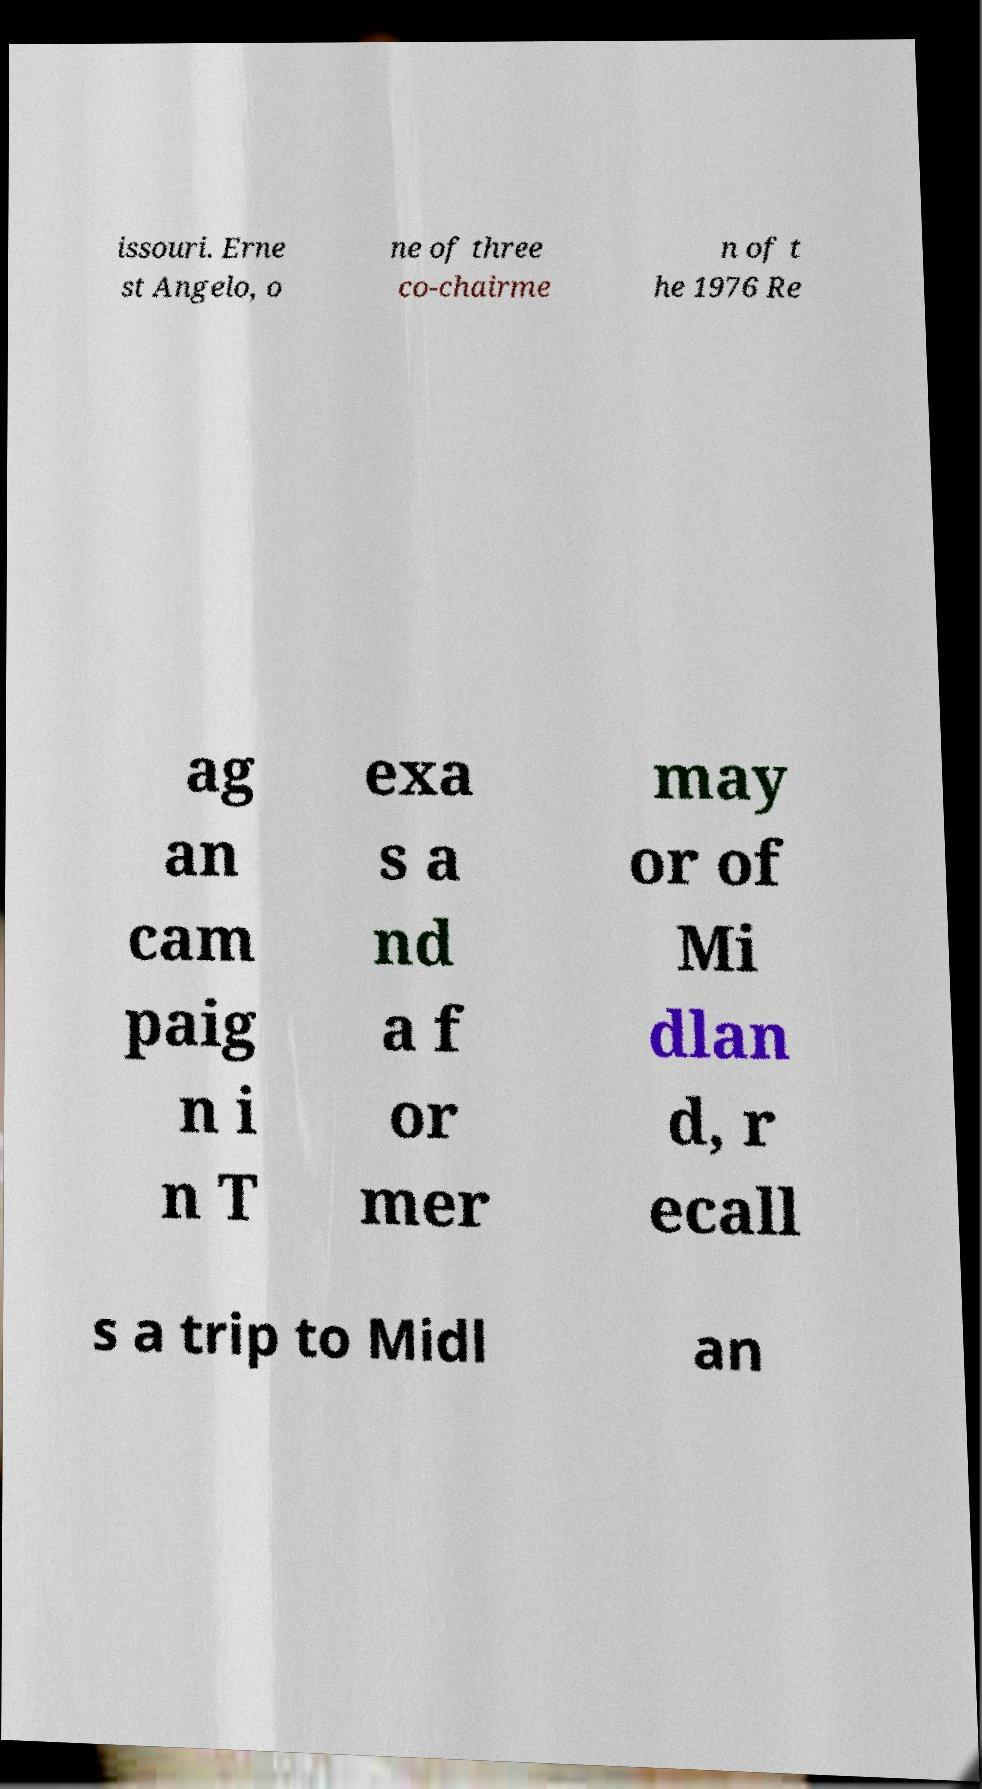I need the written content from this picture converted into text. Can you do that? issouri. Erne st Angelo, o ne of three co-chairme n of t he 1976 Re ag an cam paig n i n T exa s a nd a f or mer may or of Mi dlan d, r ecall s a trip to Midl an 